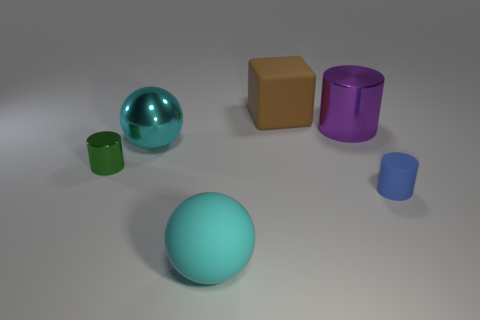What is the material of the object that is both to the right of the cyan matte sphere and to the left of the purple shiny thing?
Your response must be concise. Rubber. How many things are large objects that are to the right of the big cube or large shiny cylinders?
Provide a succinct answer. 1. Is the color of the big metal cylinder the same as the block?
Keep it short and to the point. No. Are there any other rubber cylinders of the same size as the green cylinder?
Make the answer very short. Yes. What number of things are in front of the small shiny object and to the right of the large rubber block?
Give a very brief answer. 1. There is a matte cylinder; what number of brown matte cubes are right of it?
Provide a short and direct response. 0. Are there any other brown objects of the same shape as the tiny metallic thing?
Provide a short and direct response. No. Is the shape of the small blue matte thing the same as the metal thing to the right of the brown rubber object?
Give a very brief answer. Yes. What number of cylinders are small blue rubber things or cyan metallic things?
Give a very brief answer. 1. There is a cyan object left of the big matte sphere; what is its shape?
Give a very brief answer. Sphere. 